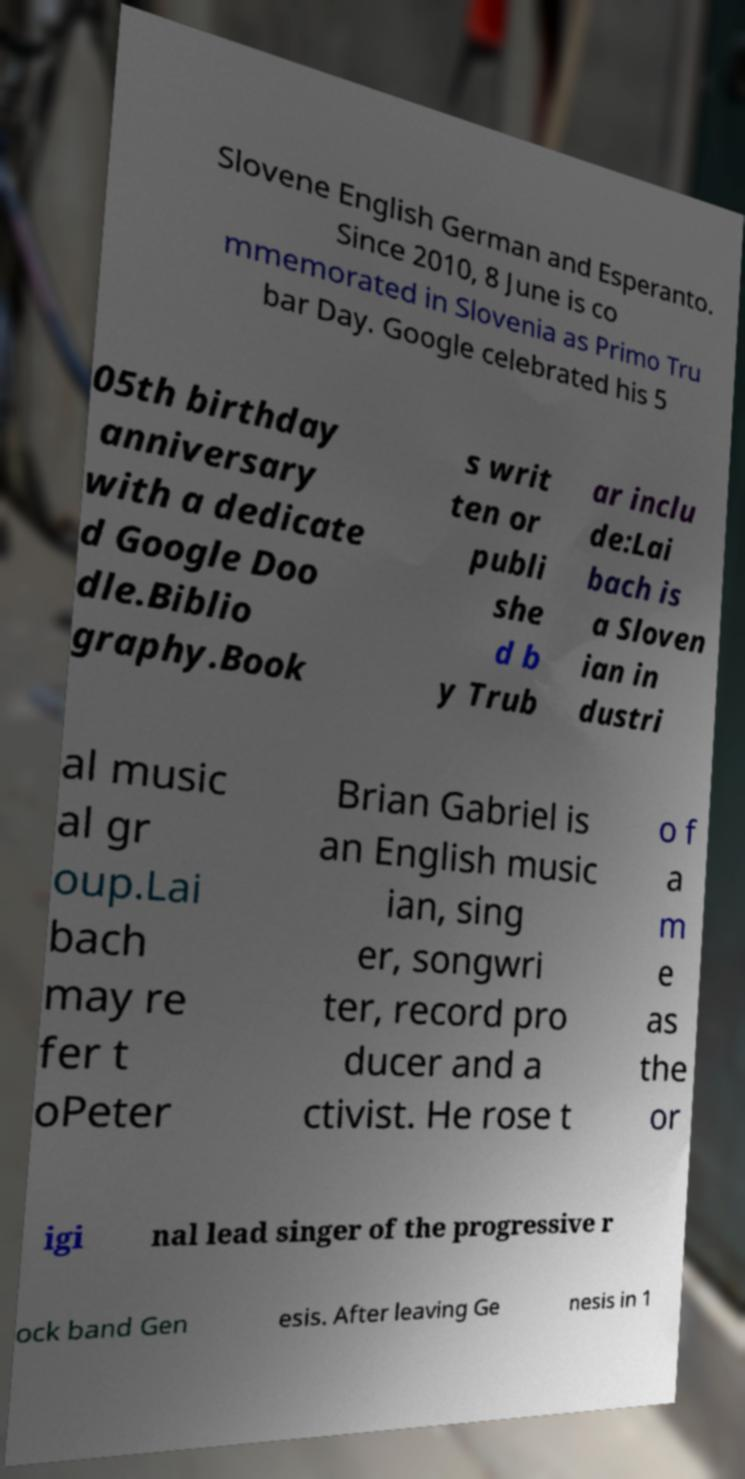Could you extract and type out the text from this image? Slovene English German and Esperanto. Since 2010, 8 June is co mmemorated in Slovenia as Primo Tru bar Day. Google celebrated his 5 05th birthday anniversary with a dedicate d Google Doo dle.Biblio graphy.Book s writ ten or publi she d b y Trub ar inclu de:Lai bach is a Sloven ian in dustri al music al gr oup.Lai bach may re fer t oPeter Brian Gabriel is an English music ian, sing er, songwri ter, record pro ducer and a ctivist. He rose t o f a m e as the or igi nal lead singer of the progressive r ock band Gen esis. After leaving Ge nesis in 1 